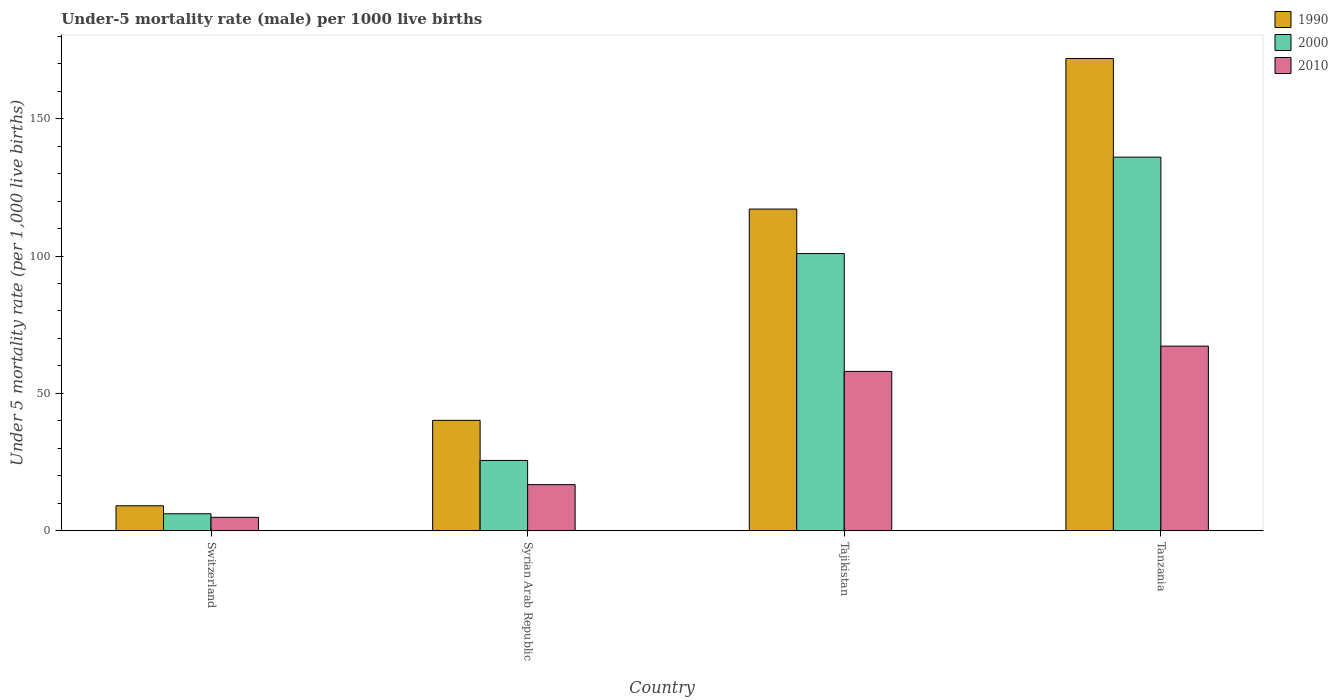How many different coloured bars are there?
Ensure brevity in your answer.  3. How many groups of bars are there?
Provide a succinct answer. 4. Are the number of bars per tick equal to the number of legend labels?
Ensure brevity in your answer.  Yes. Are the number of bars on each tick of the X-axis equal?
Keep it short and to the point. Yes. What is the label of the 4th group of bars from the left?
Make the answer very short. Tanzania. In how many cases, is the number of bars for a given country not equal to the number of legend labels?
Offer a terse response. 0. What is the under-five mortality rate in 2010 in Syrian Arab Republic?
Your response must be concise. 16.8. Across all countries, what is the maximum under-five mortality rate in 1990?
Provide a succinct answer. 171.9. Across all countries, what is the minimum under-five mortality rate in 1990?
Offer a very short reply. 9.1. In which country was the under-five mortality rate in 2010 maximum?
Your answer should be very brief. Tanzania. In which country was the under-five mortality rate in 1990 minimum?
Your response must be concise. Switzerland. What is the total under-five mortality rate in 2010 in the graph?
Make the answer very short. 146.9. What is the difference between the under-five mortality rate in 1990 in Tajikistan and that in Tanzania?
Offer a very short reply. -54.8. What is the difference between the under-five mortality rate in 1990 in Switzerland and the under-five mortality rate in 2010 in Tajikistan?
Your answer should be very brief. -48.9. What is the average under-five mortality rate in 2010 per country?
Your answer should be very brief. 36.73. What is the difference between the under-five mortality rate of/in 1990 and under-five mortality rate of/in 2000 in Syrian Arab Republic?
Your answer should be very brief. 14.6. What is the ratio of the under-five mortality rate in 2010 in Syrian Arab Republic to that in Tajikistan?
Provide a short and direct response. 0.29. Is the under-five mortality rate in 2010 in Syrian Arab Republic less than that in Tanzania?
Provide a short and direct response. Yes. What is the difference between the highest and the second highest under-five mortality rate in 2000?
Provide a short and direct response. 110.4. What is the difference between the highest and the lowest under-five mortality rate in 2000?
Provide a short and direct response. 129.8. In how many countries, is the under-five mortality rate in 1990 greater than the average under-five mortality rate in 1990 taken over all countries?
Make the answer very short. 2. What does the 2nd bar from the left in Tanzania represents?
Provide a short and direct response. 2000. Is it the case that in every country, the sum of the under-five mortality rate in 2000 and under-five mortality rate in 2010 is greater than the under-five mortality rate in 1990?
Your answer should be very brief. Yes. How many bars are there?
Your answer should be very brief. 12. Are all the bars in the graph horizontal?
Offer a terse response. No. How many countries are there in the graph?
Provide a short and direct response. 4. What is the difference between two consecutive major ticks on the Y-axis?
Your answer should be very brief. 50. Are the values on the major ticks of Y-axis written in scientific E-notation?
Give a very brief answer. No. Does the graph contain any zero values?
Offer a terse response. No. Where does the legend appear in the graph?
Your response must be concise. Top right. How many legend labels are there?
Provide a short and direct response. 3. How are the legend labels stacked?
Ensure brevity in your answer.  Vertical. What is the title of the graph?
Provide a short and direct response. Under-5 mortality rate (male) per 1000 live births. What is the label or title of the Y-axis?
Offer a terse response. Under 5 mortality rate (per 1,0 live births). What is the Under 5 mortality rate (per 1,000 live births) in 1990 in Switzerland?
Offer a terse response. 9.1. What is the Under 5 mortality rate (per 1,000 live births) of 2010 in Switzerland?
Your answer should be compact. 4.9. What is the Under 5 mortality rate (per 1,000 live births) of 1990 in Syrian Arab Republic?
Your answer should be very brief. 40.2. What is the Under 5 mortality rate (per 1,000 live births) in 2000 in Syrian Arab Republic?
Keep it short and to the point. 25.6. What is the Under 5 mortality rate (per 1,000 live births) in 1990 in Tajikistan?
Your answer should be very brief. 117.1. What is the Under 5 mortality rate (per 1,000 live births) of 2000 in Tajikistan?
Keep it short and to the point. 100.9. What is the Under 5 mortality rate (per 1,000 live births) of 1990 in Tanzania?
Your answer should be compact. 171.9. What is the Under 5 mortality rate (per 1,000 live births) in 2000 in Tanzania?
Keep it short and to the point. 136. What is the Under 5 mortality rate (per 1,000 live births) in 2010 in Tanzania?
Keep it short and to the point. 67.2. Across all countries, what is the maximum Under 5 mortality rate (per 1,000 live births) in 1990?
Make the answer very short. 171.9. Across all countries, what is the maximum Under 5 mortality rate (per 1,000 live births) in 2000?
Make the answer very short. 136. Across all countries, what is the maximum Under 5 mortality rate (per 1,000 live births) of 2010?
Your answer should be very brief. 67.2. What is the total Under 5 mortality rate (per 1,000 live births) in 1990 in the graph?
Your answer should be compact. 338.3. What is the total Under 5 mortality rate (per 1,000 live births) in 2000 in the graph?
Ensure brevity in your answer.  268.7. What is the total Under 5 mortality rate (per 1,000 live births) of 2010 in the graph?
Ensure brevity in your answer.  146.9. What is the difference between the Under 5 mortality rate (per 1,000 live births) in 1990 in Switzerland and that in Syrian Arab Republic?
Give a very brief answer. -31.1. What is the difference between the Under 5 mortality rate (per 1,000 live births) of 2000 in Switzerland and that in Syrian Arab Republic?
Provide a short and direct response. -19.4. What is the difference between the Under 5 mortality rate (per 1,000 live births) in 1990 in Switzerland and that in Tajikistan?
Your answer should be very brief. -108. What is the difference between the Under 5 mortality rate (per 1,000 live births) of 2000 in Switzerland and that in Tajikistan?
Make the answer very short. -94.7. What is the difference between the Under 5 mortality rate (per 1,000 live births) in 2010 in Switzerland and that in Tajikistan?
Offer a very short reply. -53.1. What is the difference between the Under 5 mortality rate (per 1,000 live births) in 1990 in Switzerland and that in Tanzania?
Keep it short and to the point. -162.8. What is the difference between the Under 5 mortality rate (per 1,000 live births) in 2000 in Switzerland and that in Tanzania?
Give a very brief answer. -129.8. What is the difference between the Under 5 mortality rate (per 1,000 live births) in 2010 in Switzerland and that in Tanzania?
Give a very brief answer. -62.3. What is the difference between the Under 5 mortality rate (per 1,000 live births) of 1990 in Syrian Arab Republic and that in Tajikistan?
Make the answer very short. -76.9. What is the difference between the Under 5 mortality rate (per 1,000 live births) in 2000 in Syrian Arab Republic and that in Tajikistan?
Your answer should be compact. -75.3. What is the difference between the Under 5 mortality rate (per 1,000 live births) of 2010 in Syrian Arab Republic and that in Tajikistan?
Give a very brief answer. -41.2. What is the difference between the Under 5 mortality rate (per 1,000 live births) in 1990 in Syrian Arab Republic and that in Tanzania?
Keep it short and to the point. -131.7. What is the difference between the Under 5 mortality rate (per 1,000 live births) in 2000 in Syrian Arab Republic and that in Tanzania?
Provide a short and direct response. -110.4. What is the difference between the Under 5 mortality rate (per 1,000 live births) in 2010 in Syrian Arab Republic and that in Tanzania?
Give a very brief answer. -50.4. What is the difference between the Under 5 mortality rate (per 1,000 live births) in 1990 in Tajikistan and that in Tanzania?
Keep it short and to the point. -54.8. What is the difference between the Under 5 mortality rate (per 1,000 live births) in 2000 in Tajikistan and that in Tanzania?
Make the answer very short. -35.1. What is the difference between the Under 5 mortality rate (per 1,000 live births) of 2010 in Tajikistan and that in Tanzania?
Ensure brevity in your answer.  -9.2. What is the difference between the Under 5 mortality rate (per 1,000 live births) of 1990 in Switzerland and the Under 5 mortality rate (per 1,000 live births) of 2000 in Syrian Arab Republic?
Provide a succinct answer. -16.5. What is the difference between the Under 5 mortality rate (per 1,000 live births) of 1990 in Switzerland and the Under 5 mortality rate (per 1,000 live births) of 2000 in Tajikistan?
Provide a short and direct response. -91.8. What is the difference between the Under 5 mortality rate (per 1,000 live births) in 1990 in Switzerland and the Under 5 mortality rate (per 1,000 live births) in 2010 in Tajikistan?
Offer a terse response. -48.9. What is the difference between the Under 5 mortality rate (per 1,000 live births) of 2000 in Switzerland and the Under 5 mortality rate (per 1,000 live births) of 2010 in Tajikistan?
Your answer should be compact. -51.8. What is the difference between the Under 5 mortality rate (per 1,000 live births) in 1990 in Switzerland and the Under 5 mortality rate (per 1,000 live births) in 2000 in Tanzania?
Ensure brevity in your answer.  -126.9. What is the difference between the Under 5 mortality rate (per 1,000 live births) in 1990 in Switzerland and the Under 5 mortality rate (per 1,000 live births) in 2010 in Tanzania?
Offer a very short reply. -58.1. What is the difference between the Under 5 mortality rate (per 1,000 live births) of 2000 in Switzerland and the Under 5 mortality rate (per 1,000 live births) of 2010 in Tanzania?
Keep it short and to the point. -61. What is the difference between the Under 5 mortality rate (per 1,000 live births) of 1990 in Syrian Arab Republic and the Under 5 mortality rate (per 1,000 live births) of 2000 in Tajikistan?
Give a very brief answer. -60.7. What is the difference between the Under 5 mortality rate (per 1,000 live births) of 1990 in Syrian Arab Republic and the Under 5 mortality rate (per 1,000 live births) of 2010 in Tajikistan?
Offer a terse response. -17.8. What is the difference between the Under 5 mortality rate (per 1,000 live births) of 2000 in Syrian Arab Republic and the Under 5 mortality rate (per 1,000 live births) of 2010 in Tajikistan?
Your answer should be very brief. -32.4. What is the difference between the Under 5 mortality rate (per 1,000 live births) of 1990 in Syrian Arab Republic and the Under 5 mortality rate (per 1,000 live births) of 2000 in Tanzania?
Give a very brief answer. -95.8. What is the difference between the Under 5 mortality rate (per 1,000 live births) in 1990 in Syrian Arab Republic and the Under 5 mortality rate (per 1,000 live births) in 2010 in Tanzania?
Your answer should be compact. -27. What is the difference between the Under 5 mortality rate (per 1,000 live births) of 2000 in Syrian Arab Republic and the Under 5 mortality rate (per 1,000 live births) of 2010 in Tanzania?
Your answer should be very brief. -41.6. What is the difference between the Under 5 mortality rate (per 1,000 live births) in 1990 in Tajikistan and the Under 5 mortality rate (per 1,000 live births) in 2000 in Tanzania?
Your response must be concise. -18.9. What is the difference between the Under 5 mortality rate (per 1,000 live births) of 1990 in Tajikistan and the Under 5 mortality rate (per 1,000 live births) of 2010 in Tanzania?
Keep it short and to the point. 49.9. What is the difference between the Under 5 mortality rate (per 1,000 live births) in 2000 in Tajikistan and the Under 5 mortality rate (per 1,000 live births) in 2010 in Tanzania?
Provide a short and direct response. 33.7. What is the average Under 5 mortality rate (per 1,000 live births) of 1990 per country?
Provide a short and direct response. 84.58. What is the average Under 5 mortality rate (per 1,000 live births) in 2000 per country?
Keep it short and to the point. 67.17. What is the average Under 5 mortality rate (per 1,000 live births) of 2010 per country?
Provide a succinct answer. 36.73. What is the difference between the Under 5 mortality rate (per 1,000 live births) in 1990 and Under 5 mortality rate (per 1,000 live births) in 2000 in Switzerland?
Make the answer very short. 2.9. What is the difference between the Under 5 mortality rate (per 1,000 live births) of 2000 and Under 5 mortality rate (per 1,000 live births) of 2010 in Switzerland?
Provide a succinct answer. 1.3. What is the difference between the Under 5 mortality rate (per 1,000 live births) in 1990 and Under 5 mortality rate (per 1,000 live births) in 2010 in Syrian Arab Republic?
Ensure brevity in your answer.  23.4. What is the difference between the Under 5 mortality rate (per 1,000 live births) in 1990 and Under 5 mortality rate (per 1,000 live births) in 2000 in Tajikistan?
Offer a very short reply. 16.2. What is the difference between the Under 5 mortality rate (per 1,000 live births) of 1990 and Under 5 mortality rate (per 1,000 live births) of 2010 in Tajikistan?
Provide a short and direct response. 59.1. What is the difference between the Under 5 mortality rate (per 1,000 live births) in 2000 and Under 5 mortality rate (per 1,000 live births) in 2010 in Tajikistan?
Your answer should be very brief. 42.9. What is the difference between the Under 5 mortality rate (per 1,000 live births) in 1990 and Under 5 mortality rate (per 1,000 live births) in 2000 in Tanzania?
Provide a short and direct response. 35.9. What is the difference between the Under 5 mortality rate (per 1,000 live births) of 1990 and Under 5 mortality rate (per 1,000 live births) of 2010 in Tanzania?
Make the answer very short. 104.7. What is the difference between the Under 5 mortality rate (per 1,000 live births) in 2000 and Under 5 mortality rate (per 1,000 live births) in 2010 in Tanzania?
Provide a short and direct response. 68.8. What is the ratio of the Under 5 mortality rate (per 1,000 live births) in 1990 in Switzerland to that in Syrian Arab Republic?
Your answer should be compact. 0.23. What is the ratio of the Under 5 mortality rate (per 1,000 live births) of 2000 in Switzerland to that in Syrian Arab Republic?
Your answer should be very brief. 0.24. What is the ratio of the Under 5 mortality rate (per 1,000 live births) of 2010 in Switzerland to that in Syrian Arab Republic?
Offer a very short reply. 0.29. What is the ratio of the Under 5 mortality rate (per 1,000 live births) of 1990 in Switzerland to that in Tajikistan?
Offer a terse response. 0.08. What is the ratio of the Under 5 mortality rate (per 1,000 live births) in 2000 in Switzerland to that in Tajikistan?
Provide a short and direct response. 0.06. What is the ratio of the Under 5 mortality rate (per 1,000 live births) of 2010 in Switzerland to that in Tajikistan?
Make the answer very short. 0.08. What is the ratio of the Under 5 mortality rate (per 1,000 live births) in 1990 in Switzerland to that in Tanzania?
Your response must be concise. 0.05. What is the ratio of the Under 5 mortality rate (per 1,000 live births) in 2000 in Switzerland to that in Tanzania?
Ensure brevity in your answer.  0.05. What is the ratio of the Under 5 mortality rate (per 1,000 live births) of 2010 in Switzerland to that in Tanzania?
Your answer should be compact. 0.07. What is the ratio of the Under 5 mortality rate (per 1,000 live births) in 1990 in Syrian Arab Republic to that in Tajikistan?
Provide a succinct answer. 0.34. What is the ratio of the Under 5 mortality rate (per 1,000 live births) of 2000 in Syrian Arab Republic to that in Tajikistan?
Your response must be concise. 0.25. What is the ratio of the Under 5 mortality rate (per 1,000 live births) in 2010 in Syrian Arab Republic to that in Tajikistan?
Your response must be concise. 0.29. What is the ratio of the Under 5 mortality rate (per 1,000 live births) in 1990 in Syrian Arab Republic to that in Tanzania?
Your response must be concise. 0.23. What is the ratio of the Under 5 mortality rate (per 1,000 live births) of 2000 in Syrian Arab Republic to that in Tanzania?
Offer a very short reply. 0.19. What is the ratio of the Under 5 mortality rate (per 1,000 live births) in 1990 in Tajikistan to that in Tanzania?
Give a very brief answer. 0.68. What is the ratio of the Under 5 mortality rate (per 1,000 live births) in 2000 in Tajikistan to that in Tanzania?
Your answer should be compact. 0.74. What is the ratio of the Under 5 mortality rate (per 1,000 live births) of 2010 in Tajikistan to that in Tanzania?
Ensure brevity in your answer.  0.86. What is the difference between the highest and the second highest Under 5 mortality rate (per 1,000 live births) of 1990?
Offer a terse response. 54.8. What is the difference between the highest and the second highest Under 5 mortality rate (per 1,000 live births) of 2000?
Your answer should be compact. 35.1. What is the difference between the highest and the lowest Under 5 mortality rate (per 1,000 live births) in 1990?
Your answer should be compact. 162.8. What is the difference between the highest and the lowest Under 5 mortality rate (per 1,000 live births) in 2000?
Offer a very short reply. 129.8. What is the difference between the highest and the lowest Under 5 mortality rate (per 1,000 live births) of 2010?
Keep it short and to the point. 62.3. 